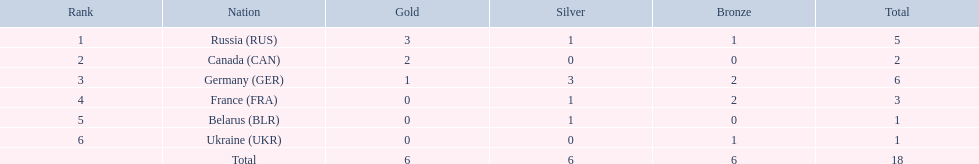Which nations obtained gold medals? Russia (RUS), Canada (CAN), Germany (GER). Of these nations, which did not acquire a silver medal? Canada (CAN). 